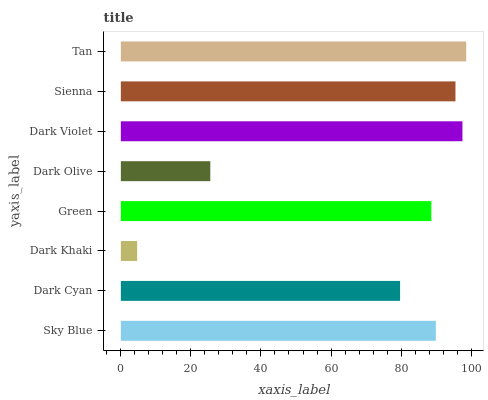Is Dark Khaki the minimum?
Answer yes or no. Yes. Is Tan the maximum?
Answer yes or no. Yes. Is Dark Cyan the minimum?
Answer yes or no. No. Is Dark Cyan the maximum?
Answer yes or no. No. Is Sky Blue greater than Dark Cyan?
Answer yes or no. Yes. Is Dark Cyan less than Sky Blue?
Answer yes or no. Yes. Is Dark Cyan greater than Sky Blue?
Answer yes or no. No. Is Sky Blue less than Dark Cyan?
Answer yes or no. No. Is Sky Blue the high median?
Answer yes or no. Yes. Is Green the low median?
Answer yes or no. Yes. Is Sienna the high median?
Answer yes or no. No. Is Sienna the low median?
Answer yes or no. No. 